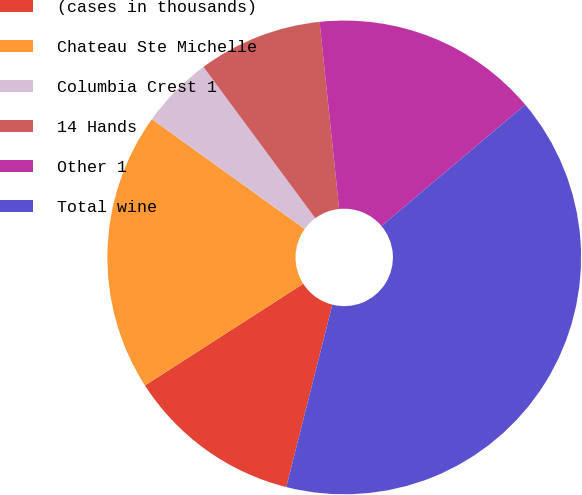<chart> <loc_0><loc_0><loc_500><loc_500><pie_chart><fcel>(cases in thousands)<fcel>Chateau Ste Michelle<fcel>Columbia Crest 1<fcel>14 Hands<fcel>Other 1<fcel>Total wine<nl><fcel>11.98%<fcel>19.01%<fcel>4.95%<fcel>8.47%<fcel>15.5%<fcel>40.09%<nl></chart> 